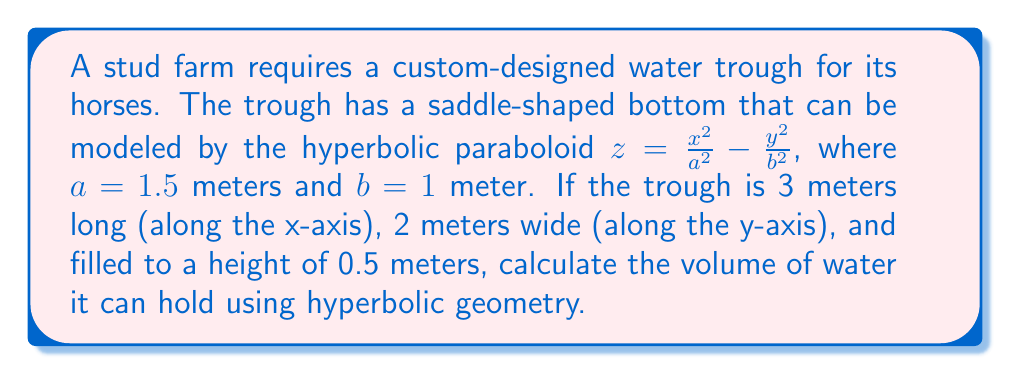What is the answer to this math problem? To solve this problem, we'll use the volume formula for a hyperbolic paraboloid and integrate it over the given domain. Here's the step-by-step solution:

1) The volume of a hyperbolic paraboloid is given by the triple integral:

   $$V = \int_{-L/2}^{L/2} \int_{-W/2}^{W/2} \int_{z(x,y)}^h dz dy dx$$

   Where $L$ is the length, $W$ is the width, $h$ is the height, and $z(x,y)$ is the equation of the surface.

2) In our case:
   $L = 3$ m, $W = 2$ m, $h = 0.5$ m, and $z(x,y) = \frac{x^2}{a^2} - \frac{y^2}{b^2}$ with $a = 1.5$ m and $b = 1$ m

3) Substituting these values:

   $$V = \int_{-1.5}^{1.5} \int_{-1}^{1} \int_{\frac{x^2}{(1.5)^2} - \frac{y^2}{1^2}}^{0.5} dz dy dx$$

4) Evaluating the inner integral:

   $$V = \int_{-1.5}^{1.5} \int_{-1}^{1} \left[0.5 - \left(\frac{x^2}{2.25} - y^2\right)\right] dy dx$$

5) Integrating with respect to y:

   $$V = \int_{-1.5}^{1.5} \left[0.5y - y^3/3 - \frac{x^2y}{2.25}\right]_{-1}^1 dx$$
   $$V = \int_{-1.5}^{1.5} \left(1 - \frac{2}{3} - \frac{2x^2}{2.25}\right) dx$$

6) Simplifying:

   $$V = \int_{-1.5}^{1.5} \left(\frac{1}{3} - \frac{8x^2}{9}\right) dx$$

7) Integrating with respect to x:

   $$V = \left[\frac{x}{3} - \frac{8x^3}{27}\right]_{-1.5}^{1.5}$$

8) Evaluating the limits:

   $$V = \left(\frac{1.5}{3} - \frac{8(1.5)^3}{27}\right) - \left(-\frac{1.5}{3} + \frac{8(-1.5)^3}{27}\right)$$
   $$V = \left(0.5 - 2\right) - \left(-0.5 + 2\right)$$
   $$V = -1.5 - 1.5 = -3$$

9) Taking the absolute value (since volume is always positive):

   $$V = 3 \text{ cubic meters}$$
Answer: 3 m³ 